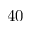Convert formula to latex. <formula><loc_0><loc_0><loc_500><loc_500>4 0</formula> 